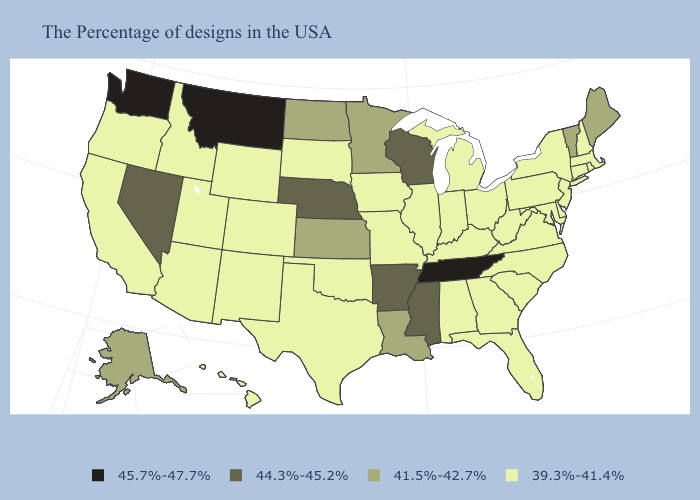Name the states that have a value in the range 41.5%-42.7%?
Short answer required. Maine, Vermont, Louisiana, Minnesota, Kansas, North Dakota, Alaska. Does the first symbol in the legend represent the smallest category?
Be succinct. No. Name the states that have a value in the range 44.3%-45.2%?
Be succinct. Wisconsin, Mississippi, Arkansas, Nebraska, Nevada. Does the map have missing data?
Concise answer only. No. What is the lowest value in the USA?
Quick response, please. 39.3%-41.4%. What is the value of Missouri?
Give a very brief answer. 39.3%-41.4%. Does the map have missing data?
Keep it brief. No. What is the value of Montana?
Be succinct. 45.7%-47.7%. What is the highest value in the Northeast ?
Keep it brief. 41.5%-42.7%. Name the states that have a value in the range 41.5%-42.7%?
Be succinct. Maine, Vermont, Louisiana, Minnesota, Kansas, North Dakota, Alaska. What is the value of Ohio?
Keep it brief. 39.3%-41.4%. Name the states that have a value in the range 41.5%-42.7%?
Keep it brief. Maine, Vermont, Louisiana, Minnesota, Kansas, North Dakota, Alaska. Name the states that have a value in the range 44.3%-45.2%?
Give a very brief answer. Wisconsin, Mississippi, Arkansas, Nebraska, Nevada. What is the lowest value in the West?
Keep it brief. 39.3%-41.4%. Which states have the lowest value in the West?
Quick response, please. Wyoming, Colorado, New Mexico, Utah, Arizona, Idaho, California, Oregon, Hawaii. 